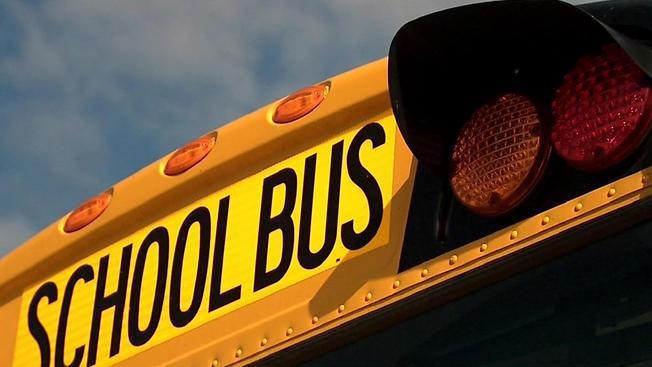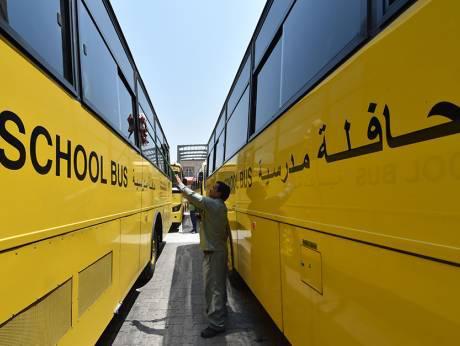The first image is the image on the left, the second image is the image on the right. Evaluate the accuracy of this statement regarding the images: "The buses on the right are parked in two columns that are close together.". Is it true? Answer yes or no. Yes. The first image is the image on the left, the second image is the image on the right. For the images shown, is this caption "One image shows parked yellow school buses viewed through chain link fence, and the other image shows a 'diminishing perspective' view of the length of at least one bus." true? Answer yes or no. No. 